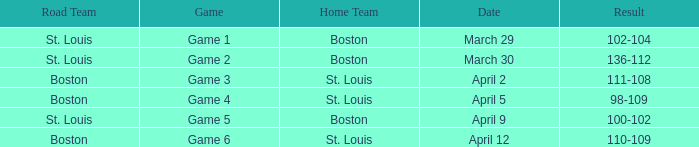On what Date is Game 3 with Boston Road Team? April 2. 